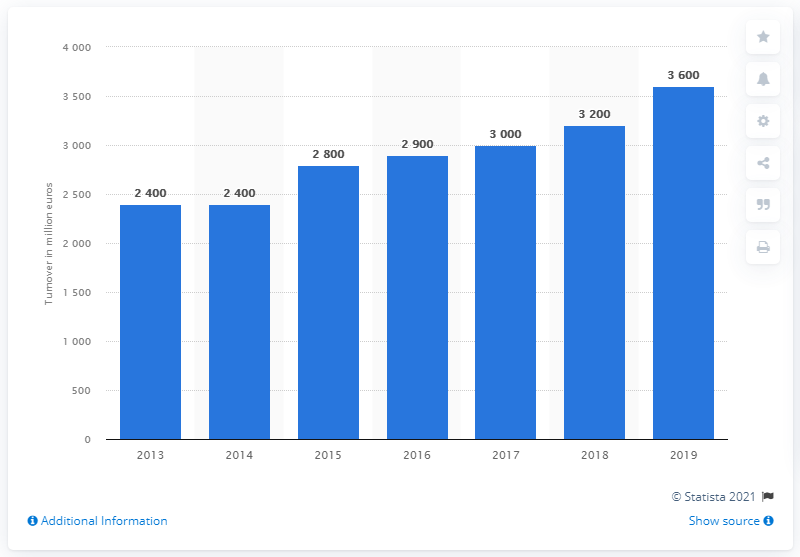Indicate a few pertinent items in this graphic. Gebr. Heinemann's global turnover in 2019 was approximately 3,600. 